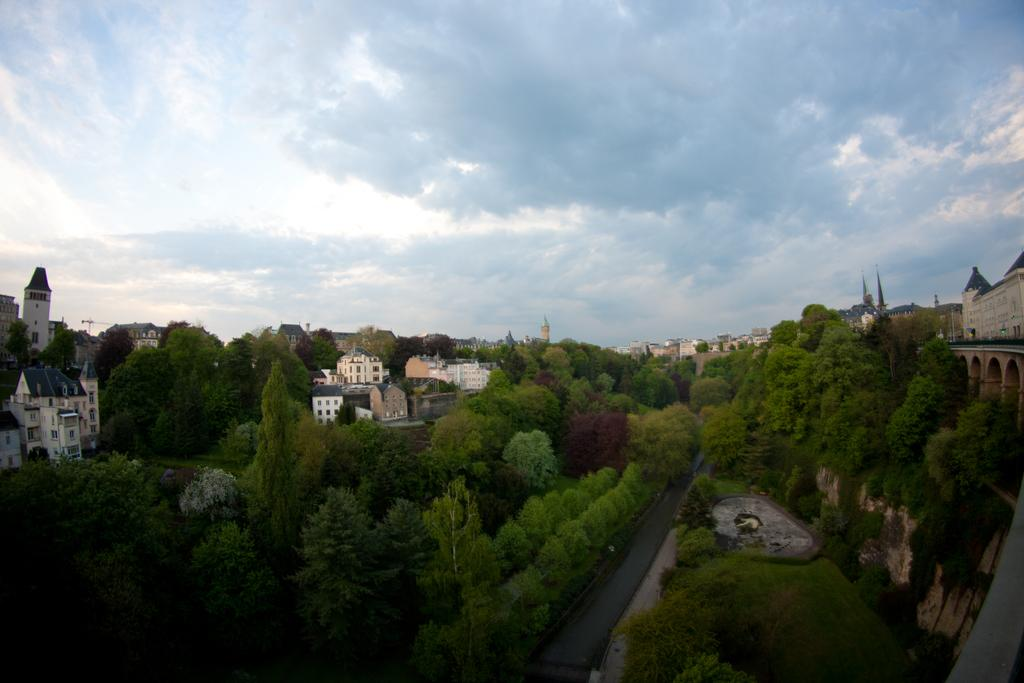What type of natural elements can be seen in the image? There are plants and trees in the image. What type of man-made structures are visible in the image? There are buildings and towers in the image. What is visible at the bottom of the image? The ground is visible in the image. What can be seen in the sky in the background? There are clouds in the sky in the background. What type of music can be heard playing in the background of the image? There is no music present in the image, as it is a still picture. What ornament is hanging from the trees in the image? There are no ornaments hanging from the trees in the image; only plants, trees, buildings, and towers are present. 